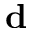Convert formula to latex. <formula><loc_0><loc_0><loc_500><loc_500>{ d }</formula> 